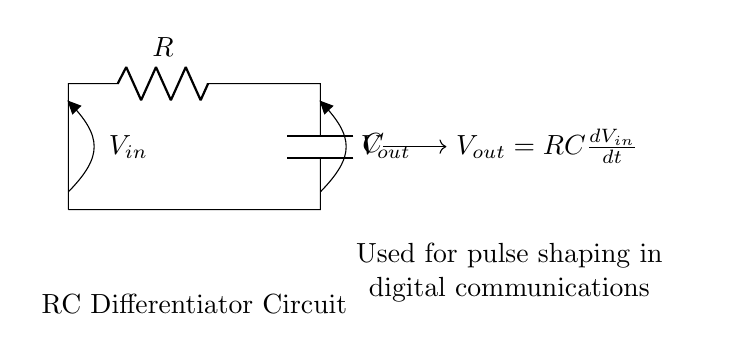What are the components in this circuit? The circuit consists of a resistor and a capacitor, which are the basic components needed to form an RC differentiator circuit. The resistor is labeled as R and the capacitor as C.
Answer: Resistor and Capacitor What is the relationship between input and output voltage? The output voltage is the derivative of the input voltage multiplied by the product of the resistor and capacitor (RC). This is indicated by the equation V out = R C (dV in/dt) shown in the diagram.
Answer: V out = R C (dV in/dt) What type of signal processing is this circuit used for? This circuit is used for pulse shaping in digital communications, as stated in the diagram. It processes input signals to create sharper transitions, which is critical for digital signal integrity.
Answer: Pulse shaping How does the resistor value affect the circuit operation? The resistor value affects the time constant of the differentiator, where a larger resistor increases the time constant, causing a slower response to changes in the input voltage. Conversely, a smaller resistor decreases the time constant, resulting in a faster response.
Answer: Affects the time constant What is the output voltage equation dependent on? The output voltage equation depends on both the resistance (R) and the capacitance (C) values, as well as the rate of change of the input voltage (dV in/dt). If R or C changes, the output response will change correspondingly.
Answer: R, C, and dV in/dt What happens to the output when the input voltage is constant? When the input voltage is constant, the derivative of the input (dV in/dt) becomes zero, resulting in the output voltage (V out) also being zero. This indicates that there is no change in the output when the input is stable.
Answer: Output becomes zero 